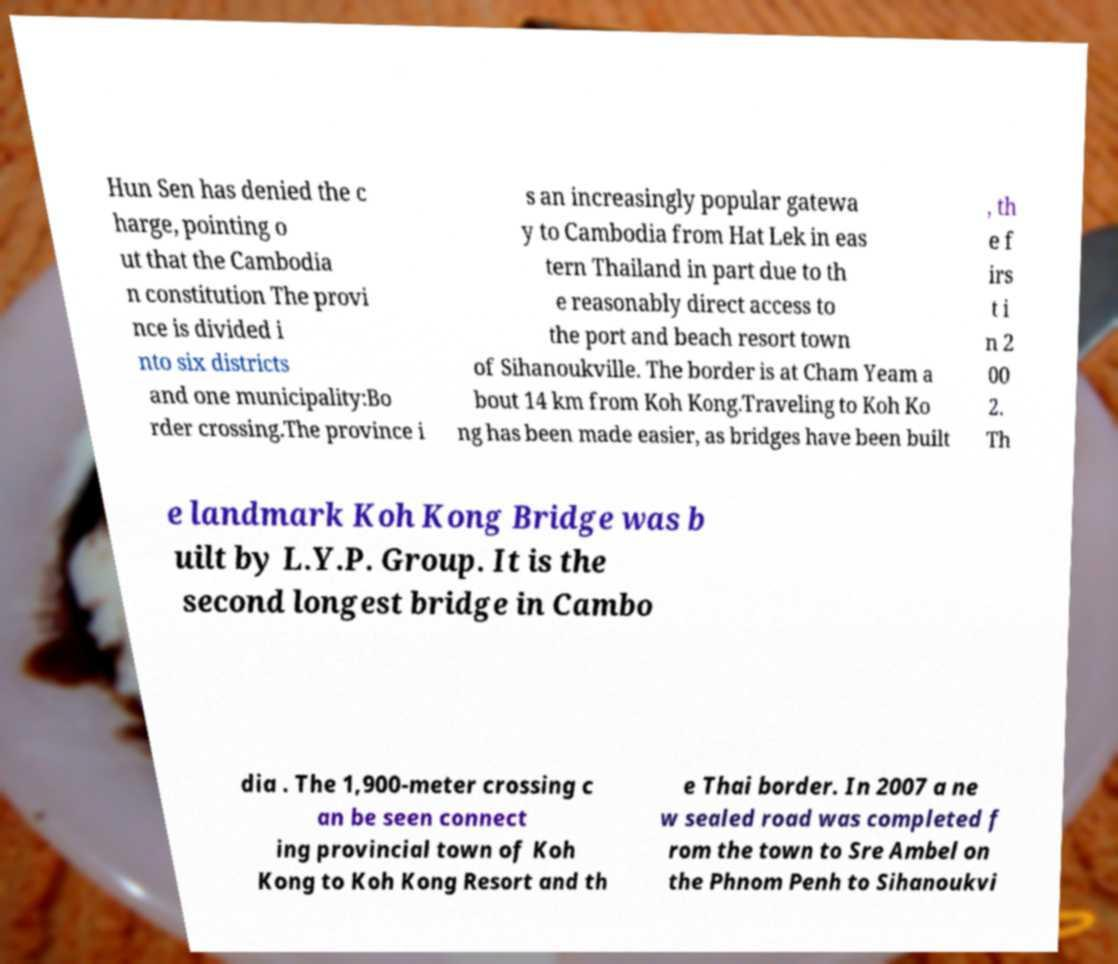Please read and relay the text visible in this image. What does it say? Hun Sen has denied the c harge, pointing o ut that the Cambodia n constitution The provi nce is divided i nto six districts and one municipality:Bo rder crossing.The province i s an increasingly popular gatewa y to Cambodia from Hat Lek in eas tern Thailand in part due to th e reasonably direct access to the port and beach resort town of Sihanoukville. The border is at Cham Yeam a bout 14 km from Koh Kong.Traveling to Koh Ko ng has been made easier, as bridges have been built , th e f irs t i n 2 00 2. Th e landmark Koh Kong Bridge was b uilt by L.Y.P. Group. It is the second longest bridge in Cambo dia . The 1,900-meter crossing c an be seen connect ing provincial town of Koh Kong to Koh Kong Resort and th e Thai border. In 2007 a ne w sealed road was completed f rom the town to Sre Ambel on the Phnom Penh to Sihanoukvi 